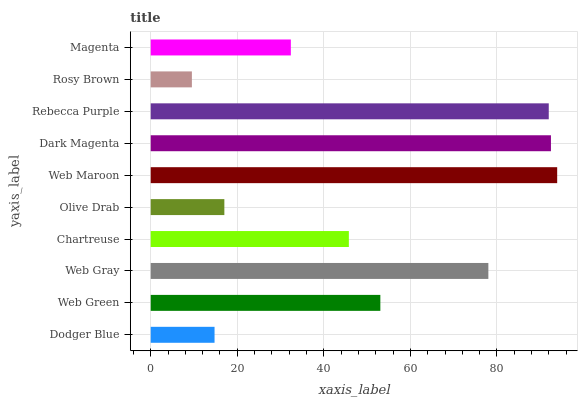Is Rosy Brown the minimum?
Answer yes or no. Yes. Is Web Maroon the maximum?
Answer yes or no. Yes. Is Web Green the minimum?
Answer yes or no. No. Is Web Green the maximum?
Answer yes or no. No. Is Web Green greater than Dodger Blue?
Answer yes or no. Yes. Is Dodger Blue less than Web Green?
Answer yes or no. Yes. Is Dodger Blue greater than Web Green?
Answer yes or no. No. Is Web Green less than Dodger Blue?
Answer yes or no. No. Is Web Green the high median?
Answer yes or no. Yes. Is Chartreuse the low median?
Answer yes or no. Yes. Is Rosy Brown the high median?
Answer yes or no. No. Is Rebecca Purple the low median?
Answer yes or no. No. 